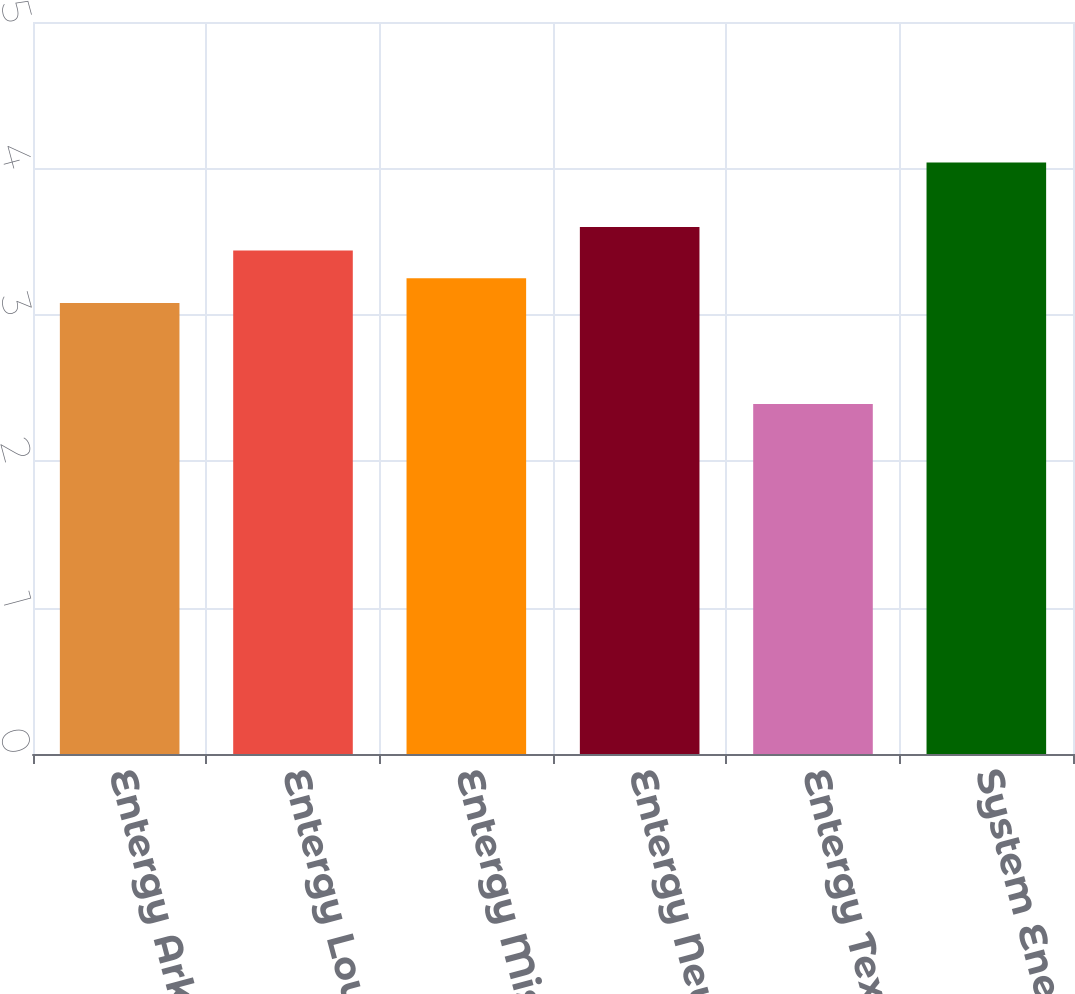<chart> <loc_0><loc_0><loc_500><loc_500><bar_chart><fcel>Entergy Arkansas<fcel>Entergy Louisiana<fcel>Entergy Mississippi<fcel>Entergy New Orleans<fcel>Entergy Texas<fcel>System Energy<nl><fcel>3.08<fcel>3.44<fcel>3.25<fcel>3.6<fcel>2.39<fcel>4.04<nl></chart> 